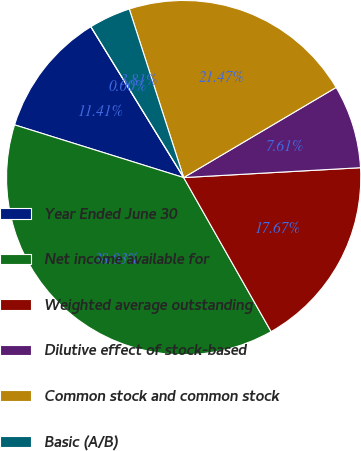Convert chart to OTSL. <chart><loc_0><loc_0><loc_500><loc_500><pie_chart><fcel>Year Ended June 30<fcel>Net income available for<fcel>Weighted average outstanding<fcel>Dilutive effect of stock-based<fcel>Common stock and common stock<fcel>Basic (A/B)<fcel>Diluted (A/C)<nl><fcel>11.41%<fcel>38.03%<fcel>17.67%<fcel>7.61%<fcel>21.47%<fcel>3.81%<fcel>0.0%<nl></chart> 